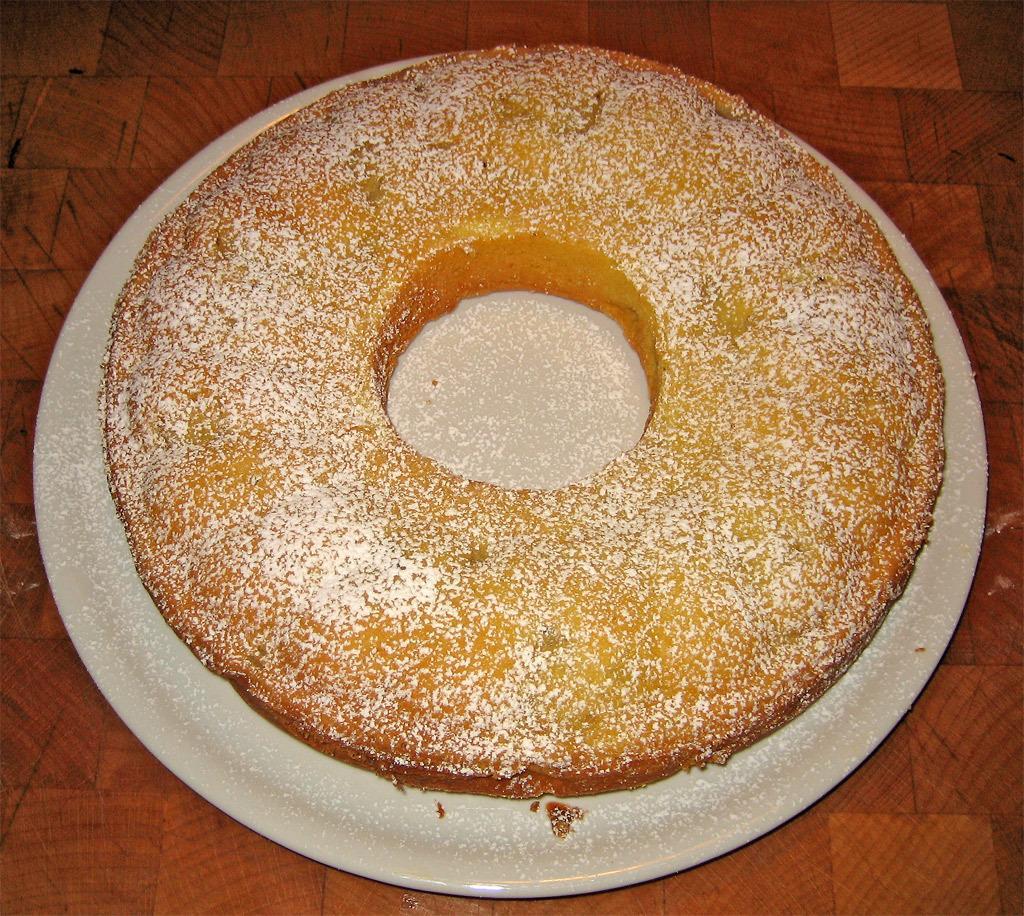Can you describe this image briefly? In the center of this picture we can see a white color platter containing the doughnut and the platter seems to be placed on the top of the wooden table. 